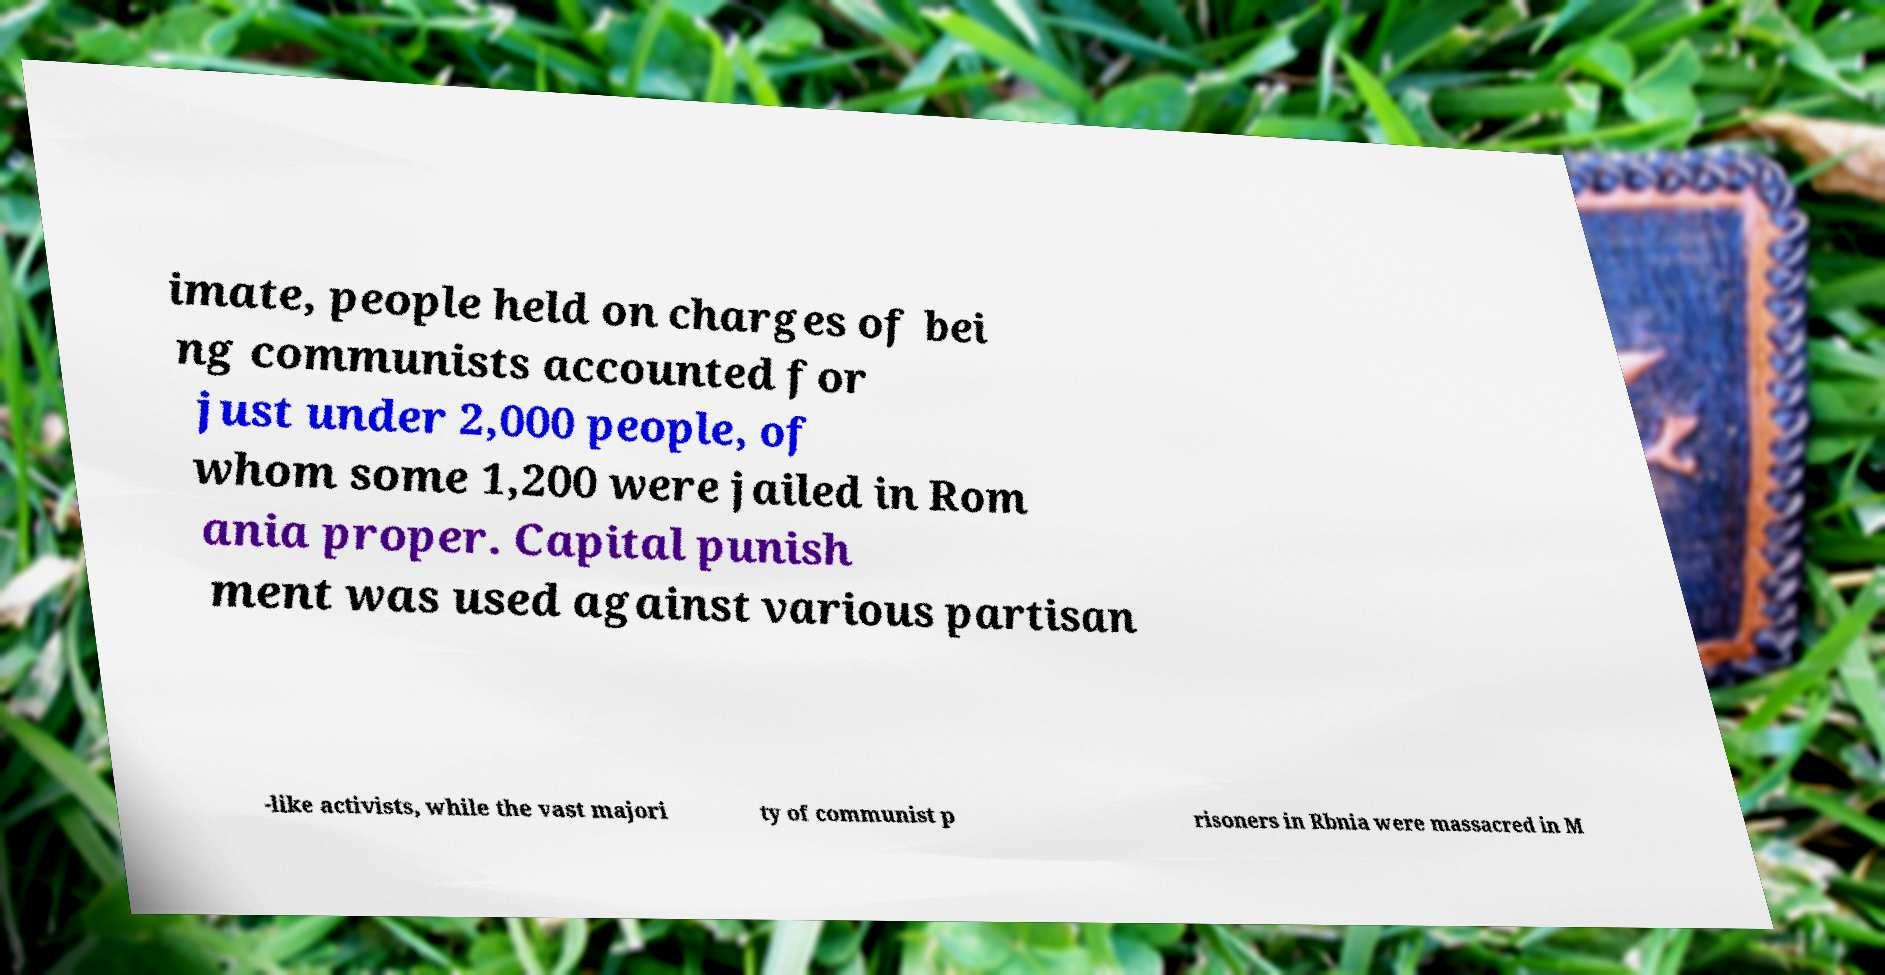What messages or text are displayed in this image? I need them in a readable, typed format. imate, people held on charges of bei ng communists accounted for just under 2,000 people, of whom some 1,200 were jailed in Rom ania proper. Capital punish ment was used against various partisan -like activists, while the vast majori ty of communist p risoners in Rbnia were massacred in M 